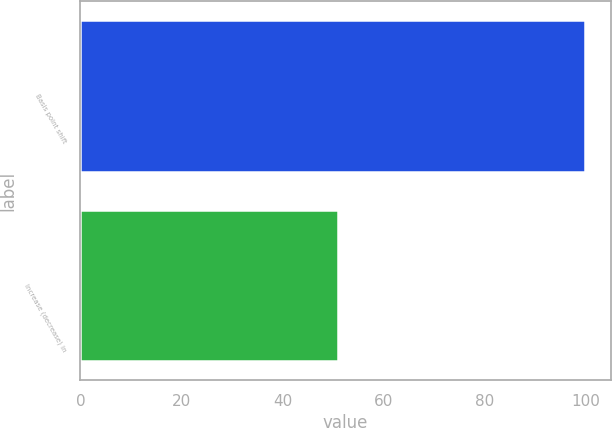Convert chart. <chart><loc_0><loc_0><loc_500><loc_500><bar_chart><fcel>Basis point shift<fcel>Increase (decrease) in<nl><fcel>100<fcel>51<nl></chart> 